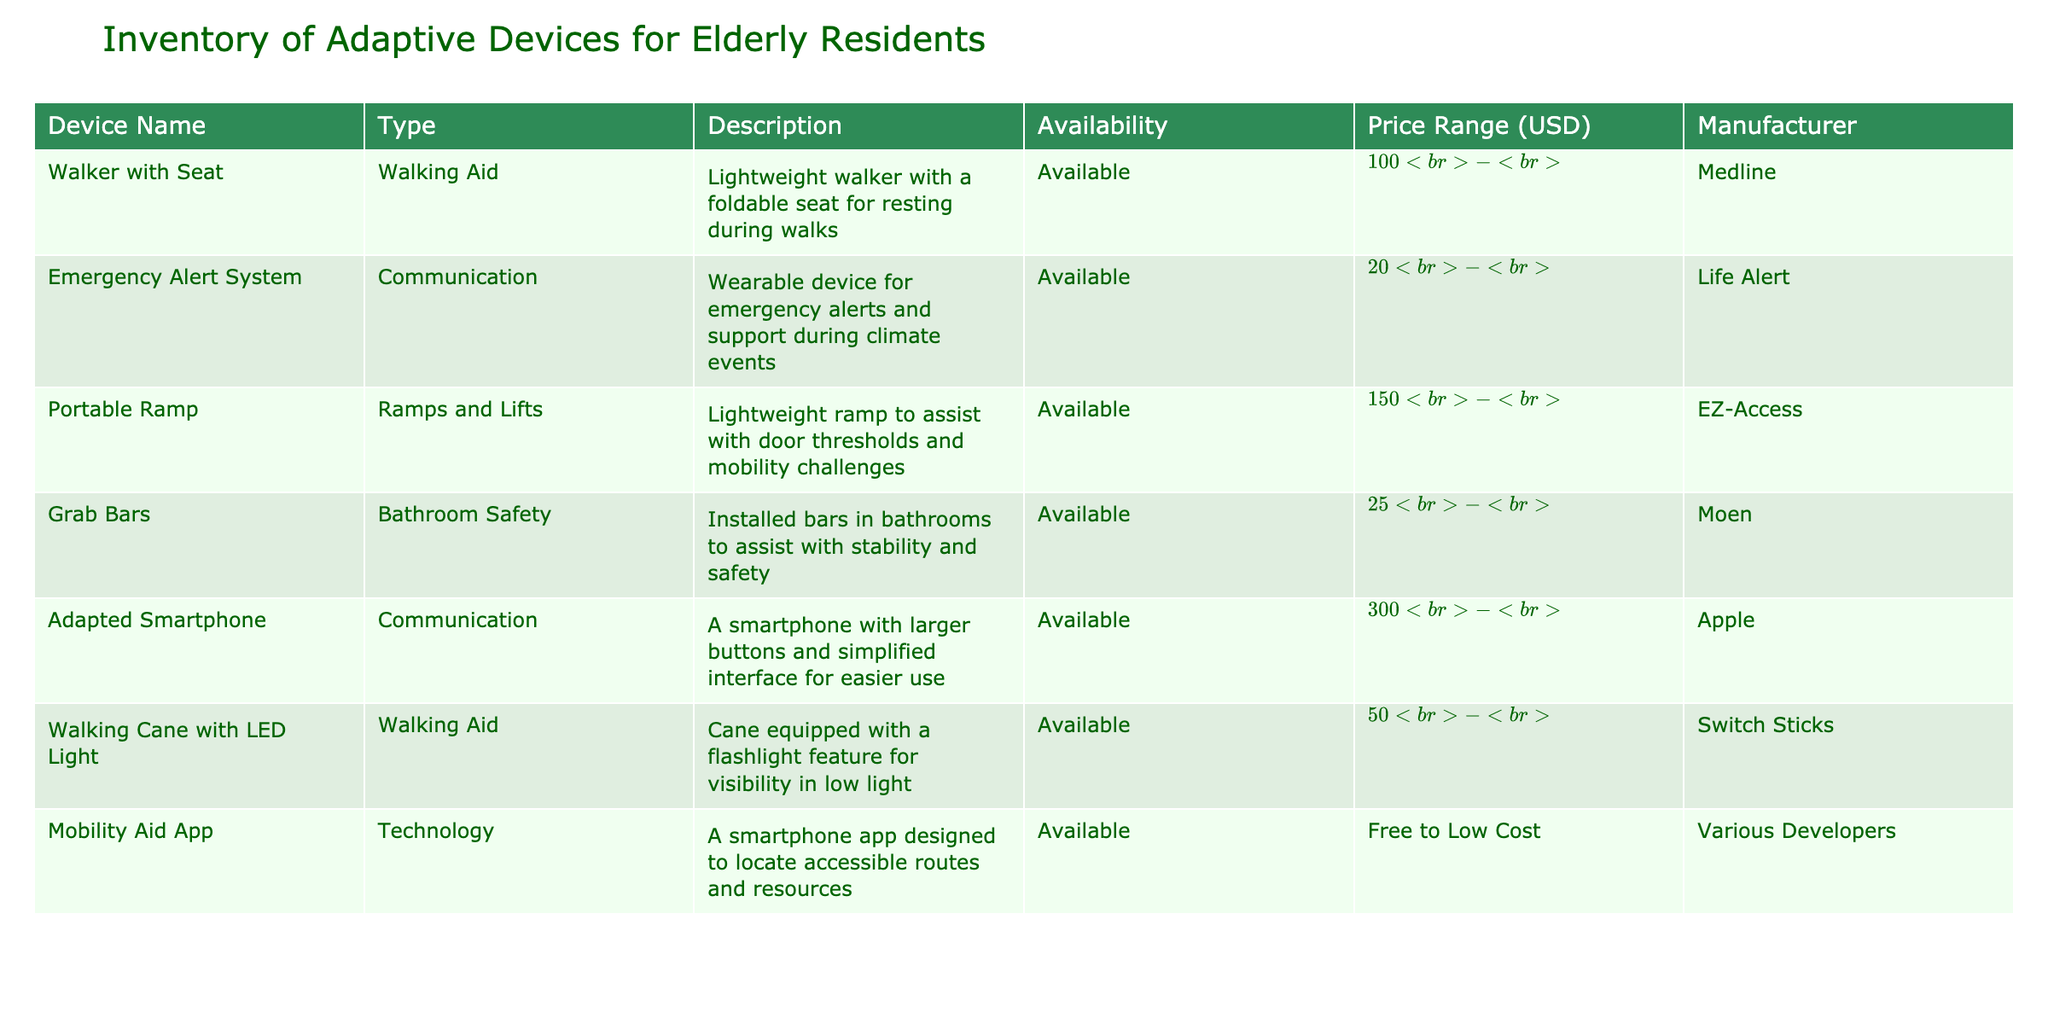What is the price range of the Walker with Seat? The price range for the Walker with Seat is listed in the table under the Price Range column. It states that the price is between $100 and $300.
Answer: $100 - $300 Are the Grab Bars available? According to the Availability column of the table, Grab Bars are marked as "Available."
Answer: Yes What type of device is the Emergency Alert System? By examining the Type column, the Emergency Alert System is classified as a Communication device.
Answer: Communication How many devices are available in the inventory? To find the total number of available devices, I count the number of rows in the table that have "Available" listed in the Availability column. There are 6 devices that are available.
Answer: 6 What is the average price range of all the walking aids listed? The two walking aids listed are the Walker with Seat ($100 - $300) and the Walking Cane with LED Light ($50 - $100). To find an average, I can look at the price ranges: For the Walker, I'll take the average of 100 and 300, which is 200. For the Cane, I average 50 and 100 to get 75. The average of 200 and 75 is (200 + 75)/2 = 137.5. The prices should be interpreted with the understanding that we take ranges into account.
Answer: $137.5 Is the Adapted Smartphone the most expensive item in the inventory? By looking at the Price Range column, the Adapted Smartphone ranges from $300 to $800. No other item in the table has a higher range as the highest price is $800, so the Adapted Smartphone is indeed the most expensive.
Answer: Yes What items have a price range lower than $200? I review each price range in the table, identifying those under $200. The Grab Bars ($25 - $100) and the Walking Cane with LED Light ($50 - $100) meet this criterion.
Answer: Grab Bars, Walking Cane with LED Light Which device is categorized as Technology? The table includes a Technology device, which is identified as the Mobility Aid App under the Type column.
Answer: Mobility Aid App If I want to buy a Portable Ramp and Grab Bars, what is the total estimated cost range? For the Portable Ramp, the price range is $150 to $400, and for the Grab Bars, it is $25 to $100. To find the total cost range, I add the lower limits and the upper limits: Lower limit: 150 + 25 = 175, Upper limit: 400 + 100 = 500, giving us a total range of $175 to $500.
Answer: $175 - $500 How many communication devices are included in this table? I check the Type column for devices classified as Communication. The Emergency Alert System and the Adapted Smartphone are the two listed, resulting in a total of 2 communication devices.
Answer: 2 